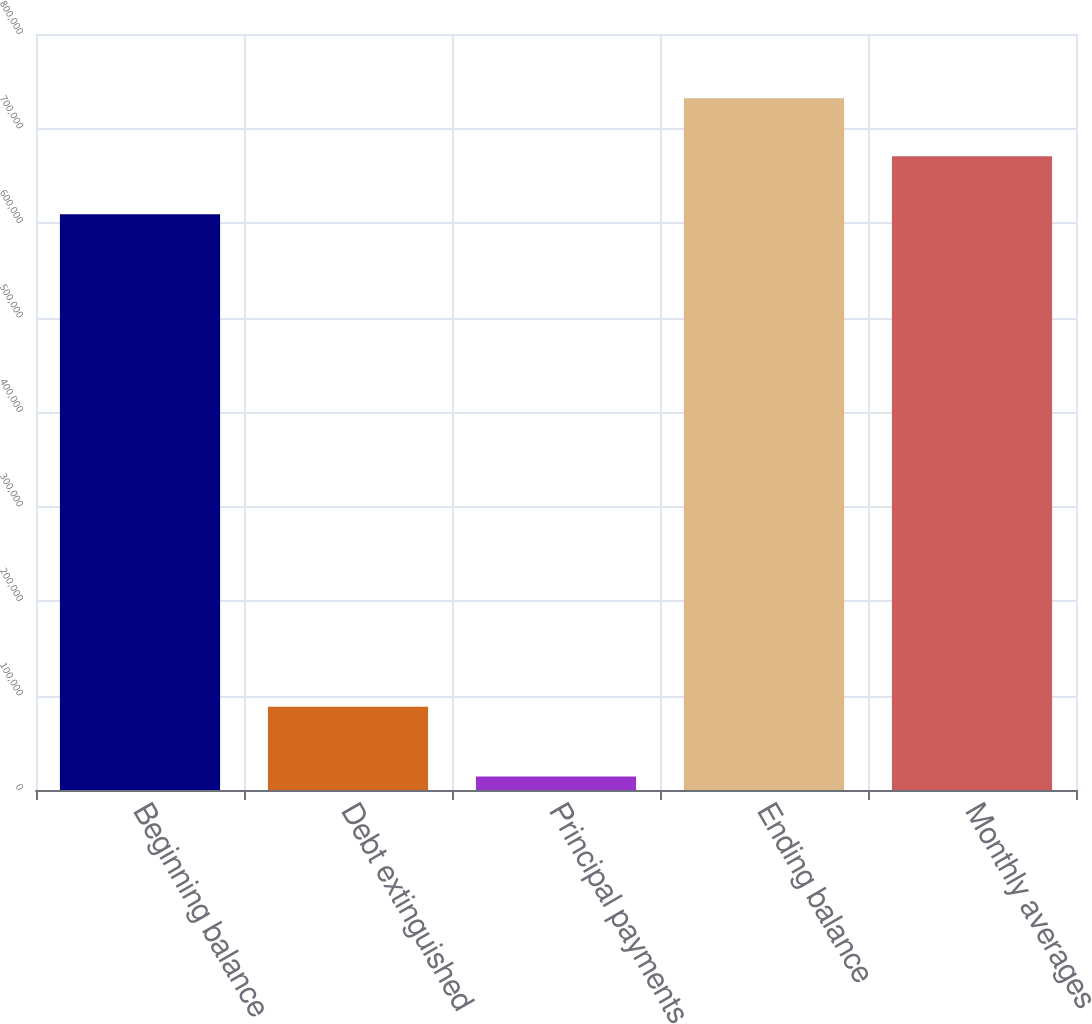<chart> <loc_0><loc_0><loc_500><loc_500><bar_chart><fcel>Beginning balance<fcel>Debt extinguished<fcel>Principal payments<fcel>Ending balance<fcel>Monthly averages<nl><fcel>609268<fcel>88182<fcel>14356<fcel>731935<fcel>670601<nl></chart> 